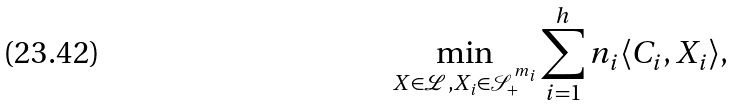Convert formula to latex. <formula><loc_0><loc_0><loc_500><loc_500>\min _ { X \in \mathcal { L } , X _ { i } \in \mathcal { S } ^ { m _ { i } } _ { + } } \sum _ { i = 1 } ^ { h } n _ { i } \langle C _ { i } , X _ { i } \rangle ,</formula> 